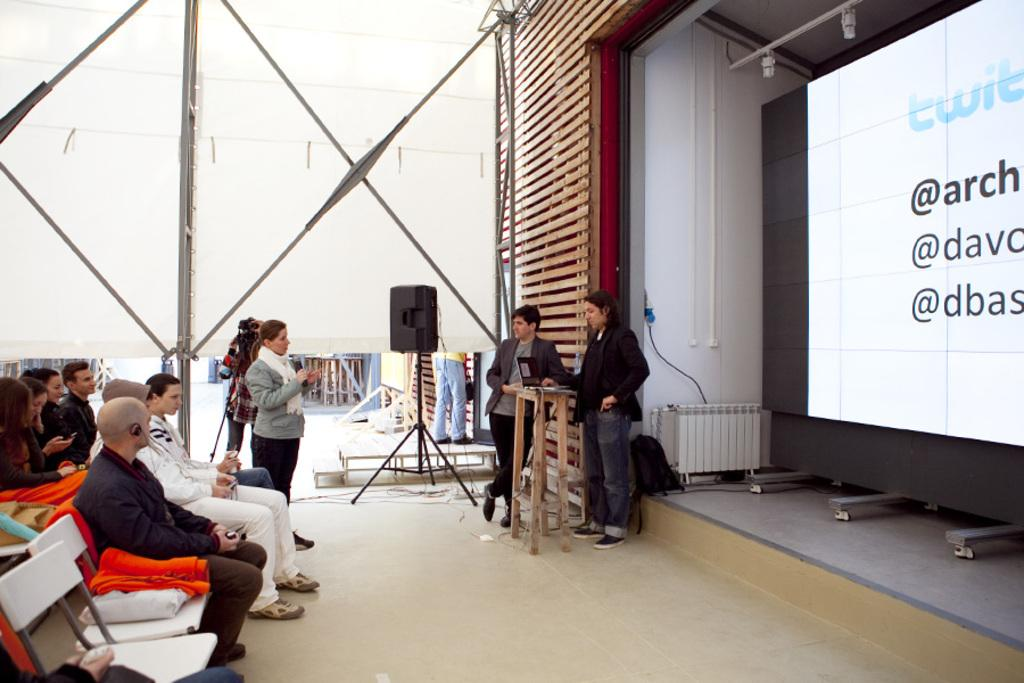What are the people in the image doing? There are people sitting on chairs and two people are standing and talking in the image. Can you describe the positions of the people in the image? Some people are sitting on chairs, while two people are standing and engaged in a conversation. What type of shop can be seen in the background of the image? There is no shop visible in the image; it only shows people sitting and talking. Can you describe the comb used by one of the people in the image? There is no comb present in the image; it only shows people sitting and talking. 